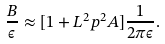<formula> <loc_0><loc_0><loc_500><loc_500>\frac { B } { \epsilon } \approx [ 1 + L ^ { 2 } p ^ { 2 } A ] \frac { 1 } { 2 \pi \epsilon } .</formula> 